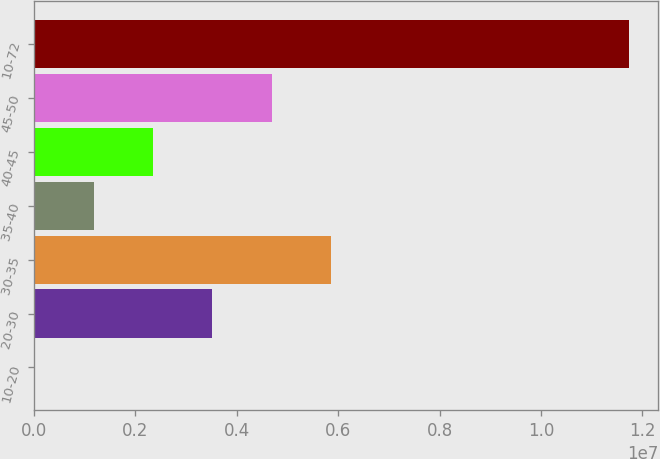<chart> <loc_0><loc_0><loc_500><loc_500><bar_chart><fcel>10-20<fcel>20-30<fcel>30-35<fcel>35-40<fcel>40-45<fcel>45-50<fcel>10-72<nl><fcel>3797<fcel>3.5213e+06<fcel>5.8663e+06<fcel>1.1763e+06<fcel>2.3488e+06<fcel>4.6938e+06<fcel>1.17288e+07<nl></chart> 